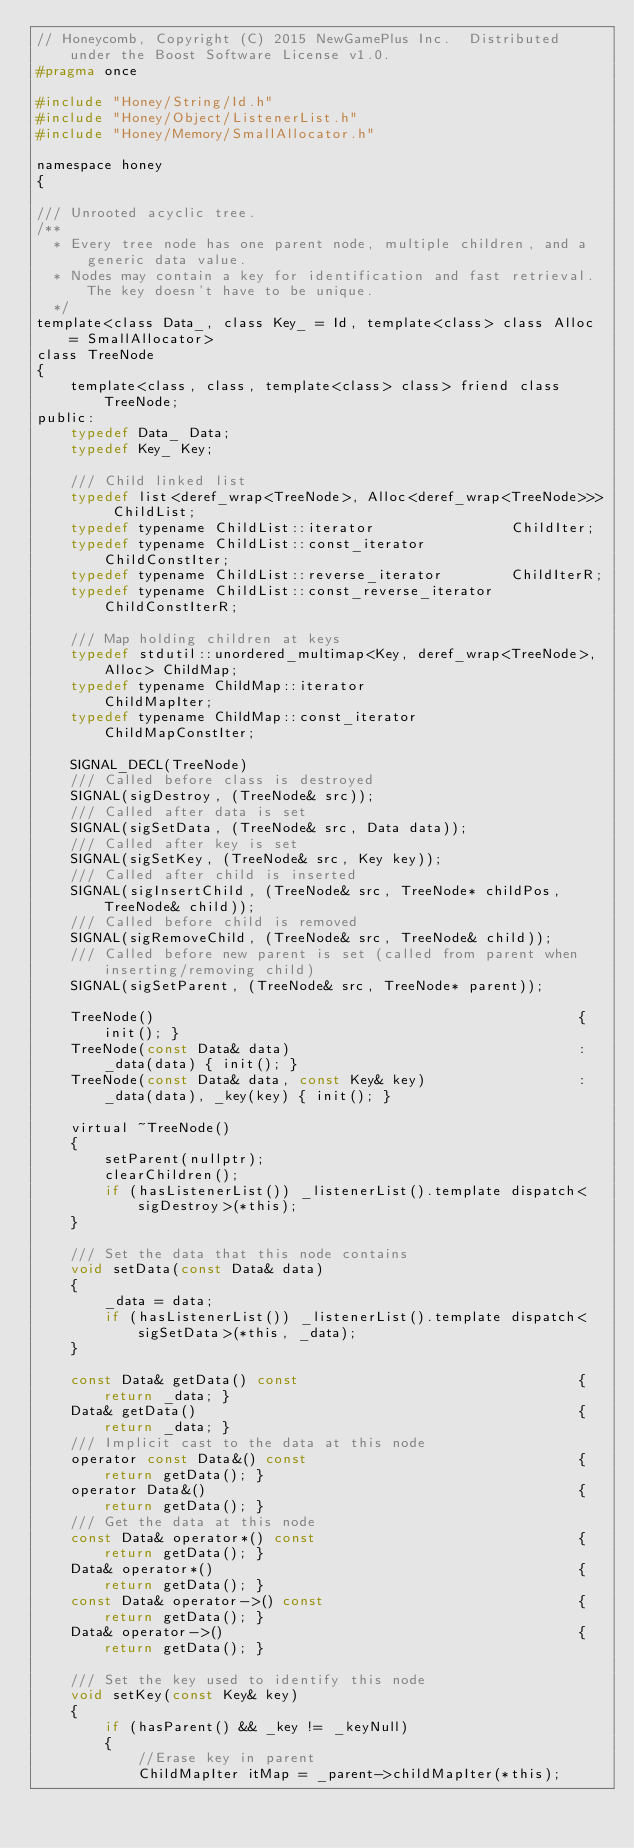Convert code to text. <code><loc_0><loc_0><loc_500><loc_500><_C_>// Honeycomb, Copyright (C) 2015 NewGamePlus Inc.  Distributed under the Boost Software License v1.0.
#pragma once

#include "Honey/String/Id.h"
#include "Honey/Object/ListenerList.h"
#include "Honey/Memory/SmallAllocator.h"

namespace honey
{

/// Unrooted acyclic tree.
/**
  * Every tree node has one parent node, multiple children, and a generic data value.
  * Nodes may contain a key for identification and fast retrieval. The key doesn't have to be unique.
  */ 
template<class Data_, class Key_ = Id, template<class> class Alloc = SmallAllocator>
class TreeNode
{
    template<class, class, template<class> class> friend class TreeNode;
public:
    typedef Data_ Data;
    typedef Key_ Key;
    
    /// Child linked list
    typedef list<deref_wrap<TreeNode>, Alloc<deref_wrap<TreeNode>>> ChildList;
    typedef typename ChildList::iterator                ChildIter;
    typedef typename ChildList::const_iterator          ChildConstIter;
    typedef typename ChildList::reverse_iterator        ChildIterR;
    typedef typename ChildList::const_reverse_iterator  ChildConstIterR;
    
    /// Map holding children at keys
    typedef stdutil::unordered_multimap<Key, deref_wrap<TreeNode>, Alloc> ChildMap;
    typedef typename ChildMap::iterator                 ChildMapIter;
    typedef typename ChildMap::const_iterator           ChildMapConstIter;

    SIGNAL_DECL(TreeNode)
    /// Called before class is destroyed
    SIGNAL(sigDestroy, (TreeNode& src));
    /// Called after data is set
    SIGNAL(sigSetData, (TreeNode& src, Data data));
    /// Called after key is set
    SIGNAL(sigSetKey, (TreeNode& src, Key key));
    /// Called after child is inserted
    SIGNAL(sigInsertChild, (TreeNode& src, TreeNode* childPos, TreeNode& child));
    /// Called before child is removed
    SIGNAL(sigRemoveChild, (TreeNode& src, TreeNode& child));
    /// Called before new parent is set (called from parent when inserting/removing child)
    SIGNAL(sigSetParent, (TreeNode& src, TreeNode* parent));

    TreeNode()                                                  { init(); }
    TreeNode(const Data& data)                                  : _data(data) { init(); }
    TreeNode(const Data& data, const Key& key)                  : _data(data), _key(key) { init(); }

    virtual ~TreeNode()
    {
        setParent(nullptr);
        clearChildren();
        if (hasListenerList()) _listenerList().template dispatch<sigDestroy>(*this);
    }

    /// Set the data that this node contains
    void setData(const Data& data)
    {
        _data = data;
        if (hasListenerList()) _listenerList().template dispatch<sigSetData>(*this, _data);
    }

    const Data& getData() const                                 { return _data; }
    Data& getData()                                             { return _data; }
    /// Implicit cast to the data at this node
    operator const Data&() const                                { return getData(); }
    operator Data&()                                            { return getData(); }
    /// Get the data at this node
    const Data& operator*() const                               { return getData(); }
    Data& operator*()                                           { return getData(); }
    const Data& operator->() const                              { return getData(); }
    Data& operator->()                                          { return getData(); }

    /// Set the key used to identify this node
    void setKey(const Key& key)
    {
        if (hasParent() && _key != _keyNull)
        {
            //Erase key in parent
            ChildMapIter itMap = _parent->childMapIter(*this);</code> 